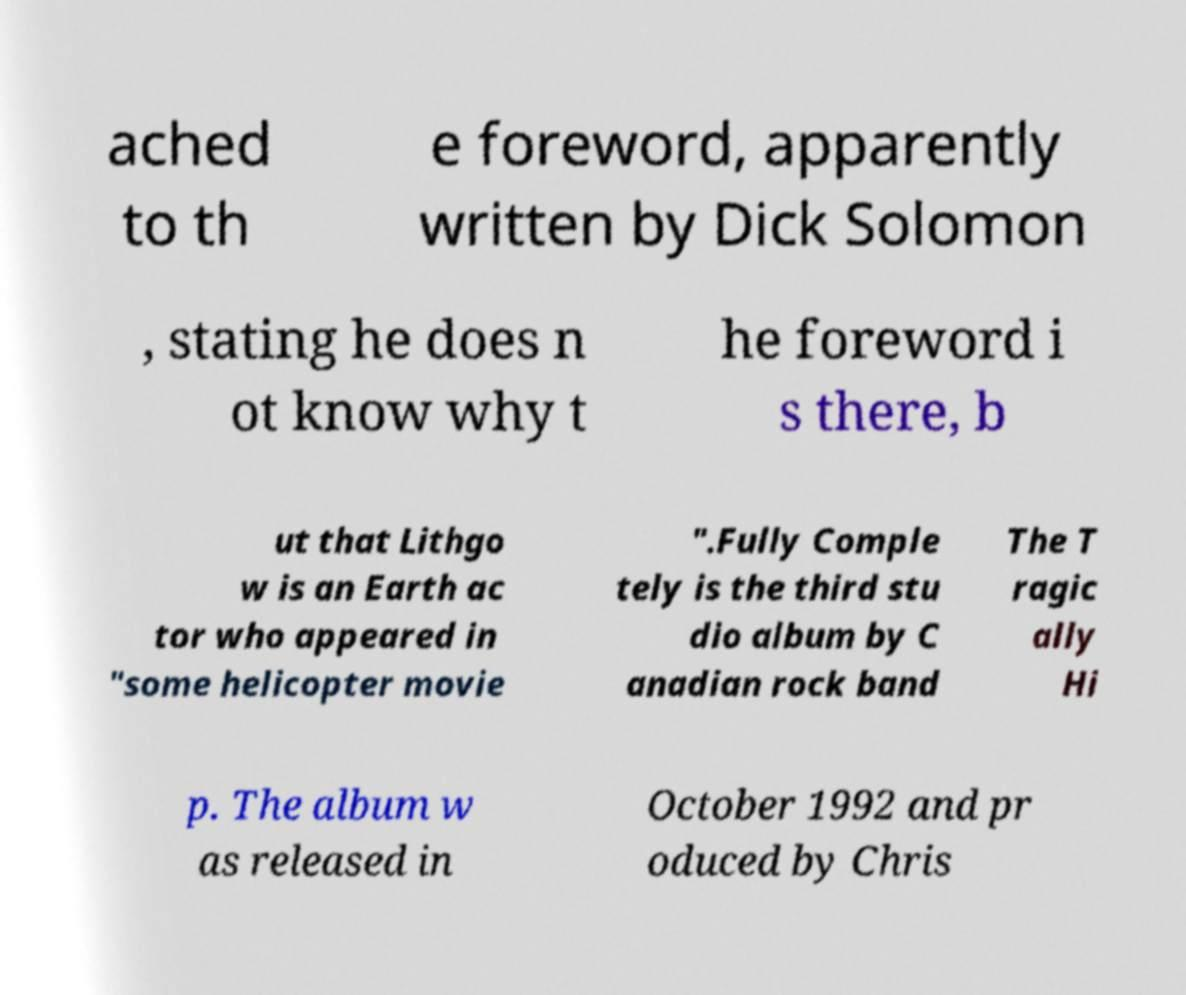For documentation purposes, I need the text within this image transcribed. Could you provide that? ached to th e foreword, apparently written by Dick Solomon , stating he does n ot know why t he foreword i s there, b ut that Lithgo w is an Earth ac tor who appeared in "some helicopter movie ".Fully Comple tely is the third stu dio album by C anadian rock band The T ragic ally Hi p. The album w as released in October 1992 and pr oduced by Chris 